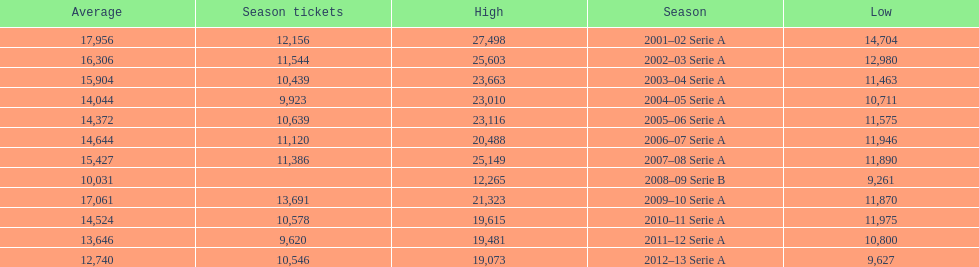What was the average in 2001 17,956. Help me parse the entirety of this table. {'header': ['Average', 'Season tickets', 'High', 'Season', 'Low'], 'rows': [['17,956', '12,156', '27,498', '2001–02 Serie A', '14,704'], ['16,306', '11,544', '25,603', '2002–03 Serie A', '12,980'], ['15,904', '10,439', '23,663', '2003–04 Serie A', '11,463'], ['14,044', '9,923', '23,010', '2004–05 Serie A', '10,711'], ['14,372', '10,639', '23,116', '2005–06 Serie A', '11,575'], ['14,644', '11,120', '20,488', '2006–07 Serie A', '11,946'], ['15,427', '11,386', '25,149', '2007–08 Serie A', '11,890'], ['10,031', '', '12,265', '2008–09 Serie B', '9,261'], ['17,061', '13,691', '21,323', '2009–10 Serie A', '11,870'], ['14,524', '10,578', '19,615', '2010–11 Serie A', '11,975'], ['13,646', '9,620', '19,481', '2011–12 Serie A', '10,800'], ['12,740', '10,546', '19,073', '2012–13 Serie A', '9,627']]} 